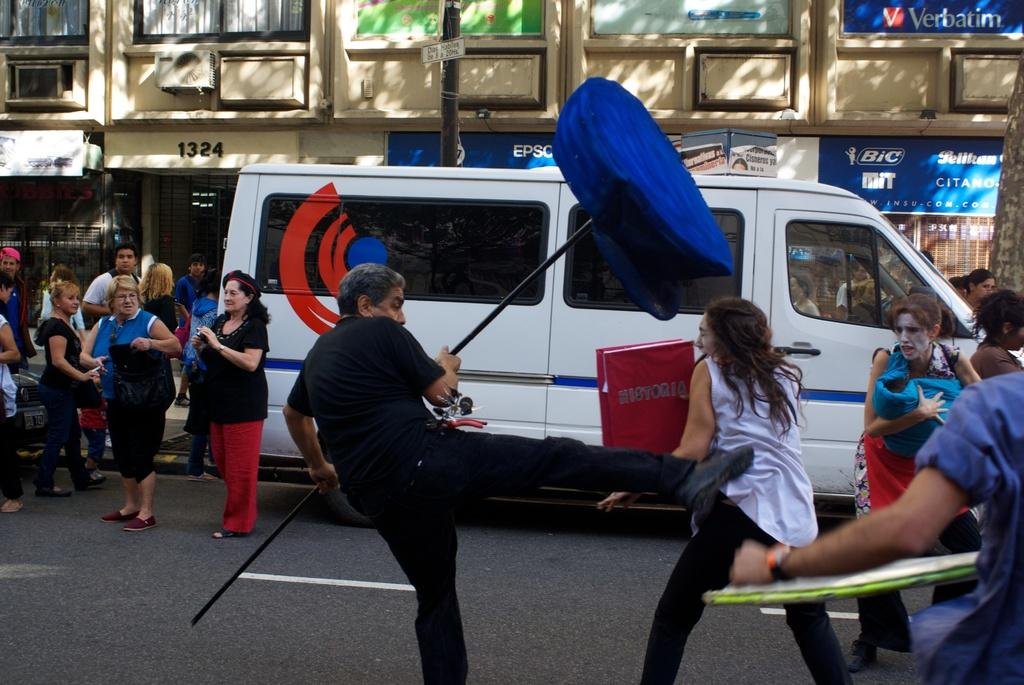<image>
Render a clear and concise summary of the photo. a man and a woman who is holding a HISTORIA book are fighting in the street with Bic and Verbatim ads on the building. 